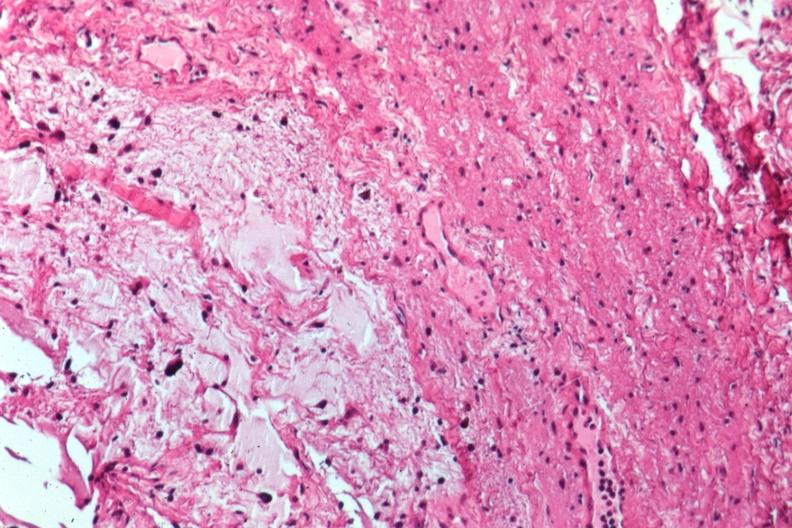s eye present?
Answer the question using a single word or phrase. Yes 